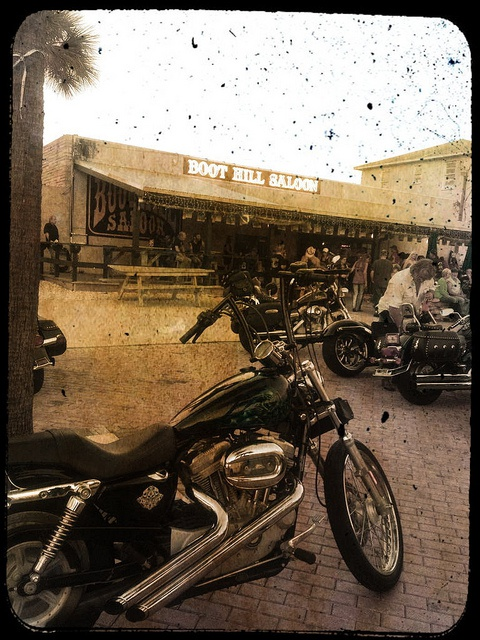Describe the objects in this image and their specific colors. I can see motorcycle in black, maroon, and gray tones, people in black, maroon, and gray tones, motorcycle in black and gray tones, motorcycle in black, gray, and tan tones, and bench in black, olive, and maroon tones in this image. 